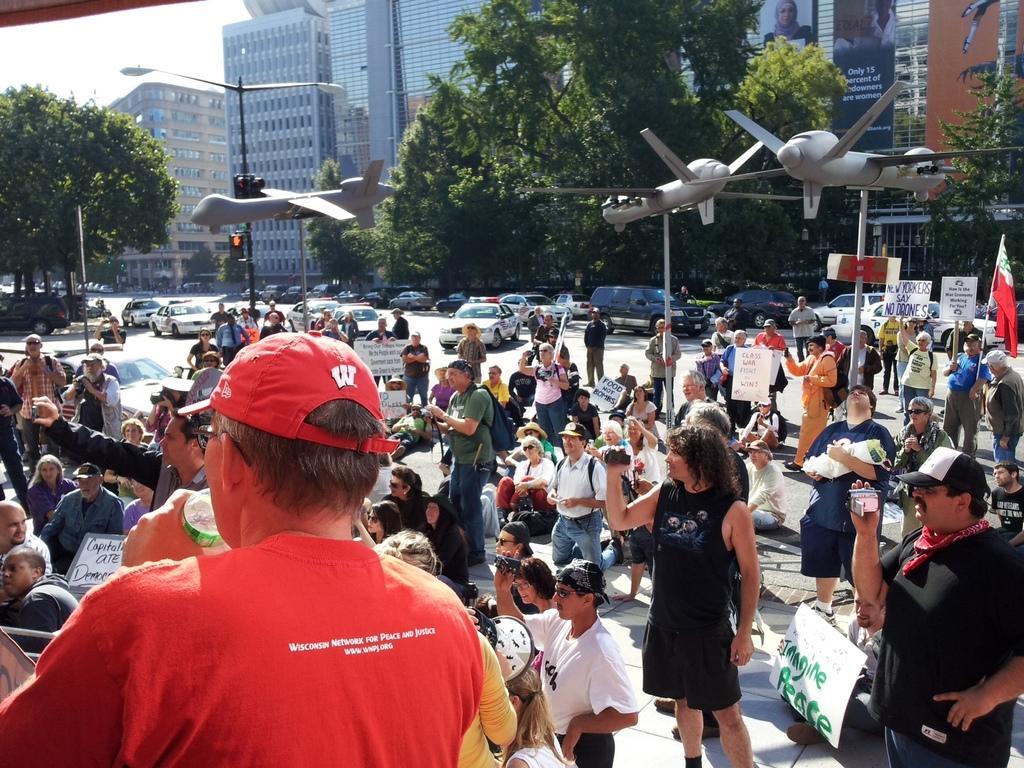Could you give a brief overview of what you see in this image? In this image, we can see people and some are holding some objects and boards. In the background, there are trees, buildings, poles, boards and there are air crafts and we can see vehicles on the road and there are railings. At the top, there is sky. 